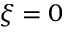Convert formula to latex. <formula><loc_0><loc_0><loc_500><loc_500>\xi = 0</formula> 